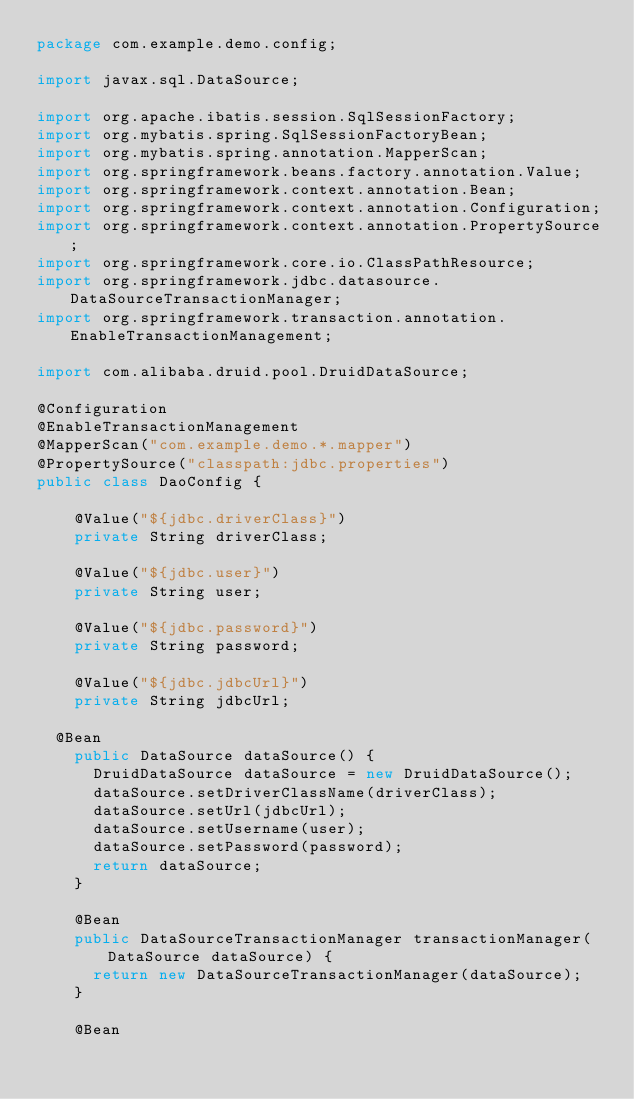<code> <loc_0><loc_0><loc_500><loc_500><_Java_>package com.example.demo.config;

import javax.sql.DataSource;

import org.apache.ibatis.session.SqlSessionFactory;
import org.mybatis.spring.SqlSessionFactoryBean;
import org.mybatis.spring.annotation.MapperScan;
import org.springframework.beans.factory.annotation.Value;
import org.springframework.context.annotation.Bean;
import org.springframework.context.annotation.Configuration;
import org.springframework.context.annotation.PropertySource;
import org.springframework.core.io.ClassPathResource;
import org.springframework.jdbc.datasource.DataSourceTransactionManager;
import org.springframework.transaction.annotation.EnableTransactionManagement;

import com.alibaba.druid.pool.DruidDataSource;

@Configuration
@EnableTransactionManagement
@MapperScan("com.example.demo.*.mapper")
@PropertySource("classpath:jdbc.properties")
public class DaoConfig {
	
    @Value("${jdbc.driverClass}")
    private String driverClass;
 
    @Value("${jdbc.user}")
    private String user;
 
    @Value("${jdbc.password}")
    private String password;
 
    @Value("${jdbc.jdbcUrl}")
    private String jdbcUrl;
	
	@Bean
    public DataSource dataSource() {
    	DruidDataSource dataSource = new DruidDataSource();
    	dataSource.setDriverClassName(driverClass);
    	dataSource.setUrl(jdbcUrl);
    	dataSource.setUsername(user);
    	dataSource.setPassword(password);
    	return dataSource;
    }
    
    @Bean
    public DataSourceTransactionManager transactionManager(DataSource dataSource) {
    	return new DataSourceTransactionManager(dataSource);
    }
    
    @Bean</code> 